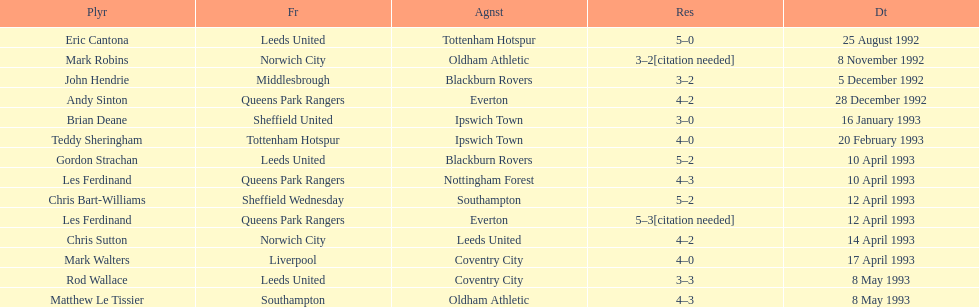What was the result of the match between queens park rangers and everton? 4-2. 